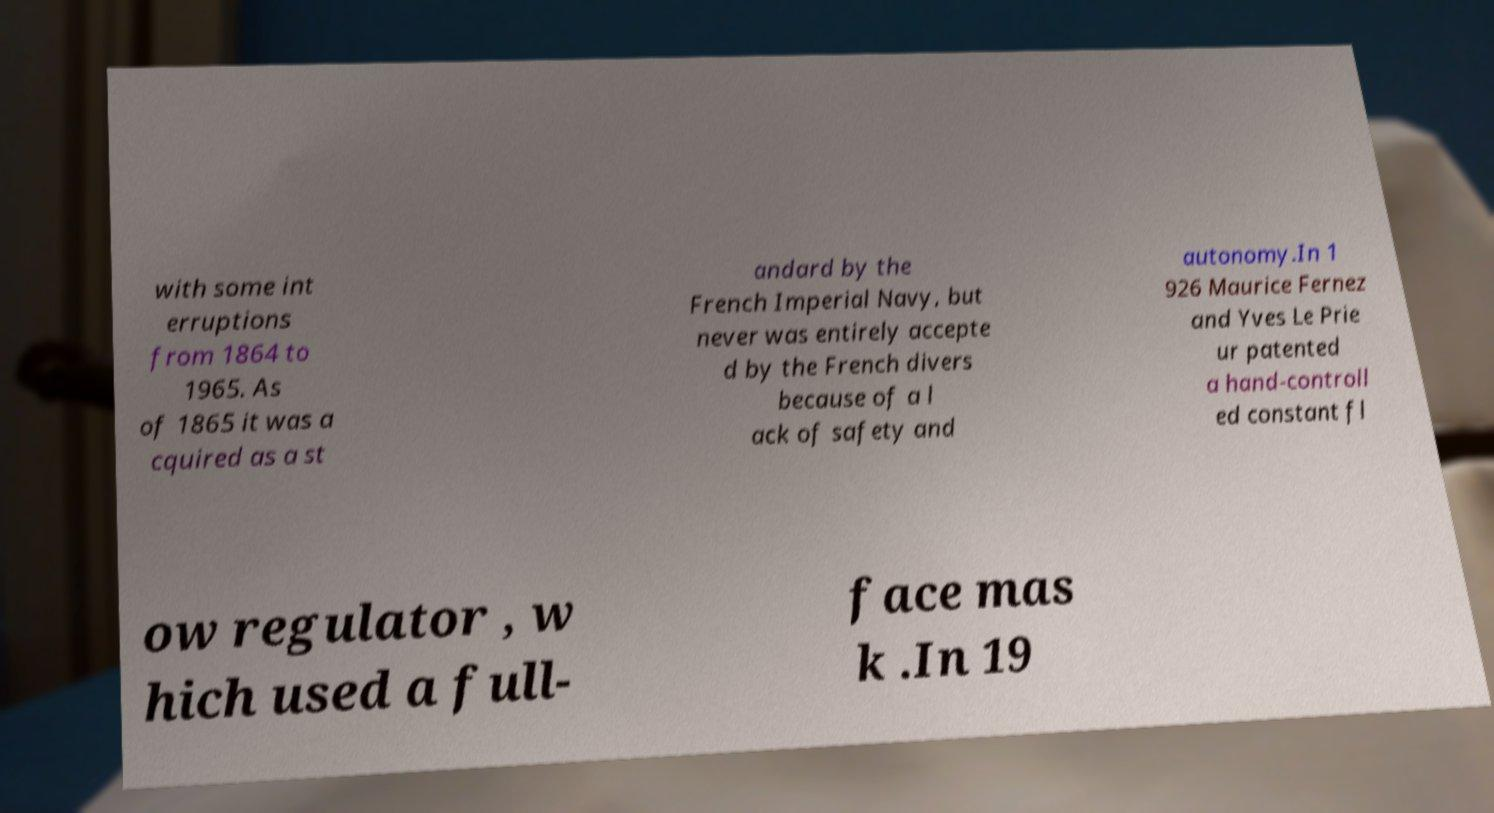For documentation purposes, I need the text within this image transcribed. Could you provide that? with some int erruptions from 1864 to 1965. As of 1865 it was a cquired as a st andard by the French Imperial Navy, but never was entirely accepte d by the French divers because of a l ack of safety and autonomy.In 1 926 Maurice Fernez and Yves Le Prie ur patented a hand-controll ed constant fl ow regulator , w hich used a full- face mas k .In 19 